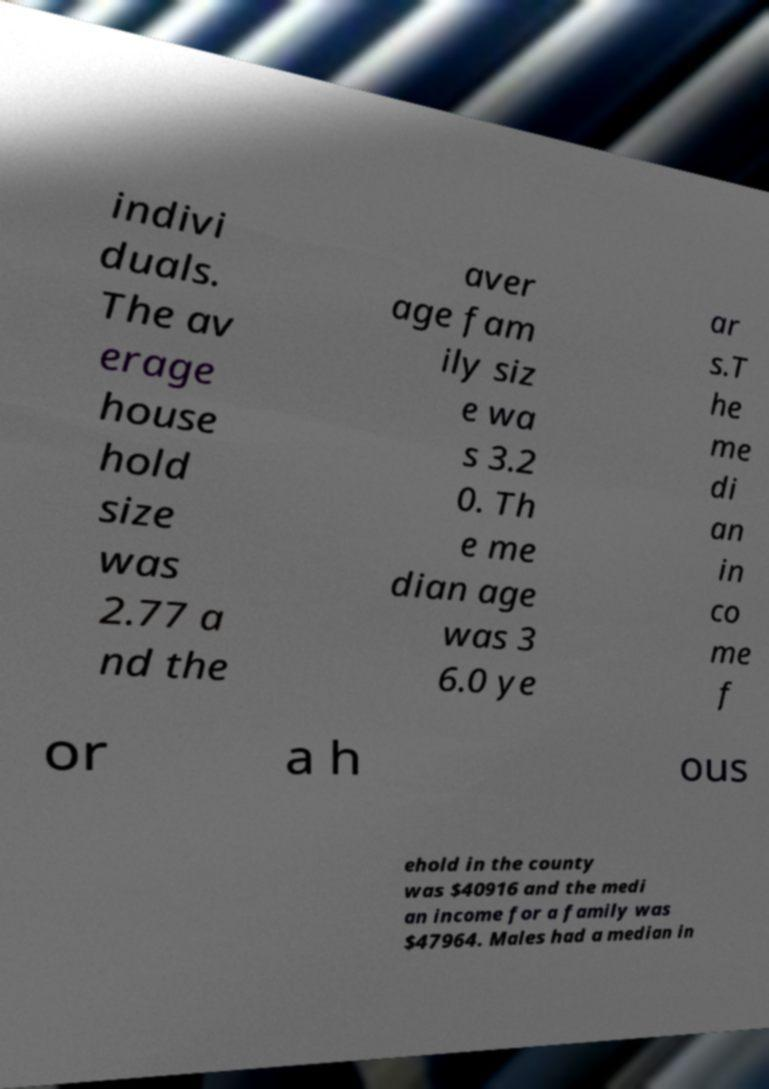Can you accurately transcribe the text from the provided image for me? indivi duals. The av erage house hold size was 2.77 a nd the aver age fam ily siz e wa s 3.2 0. Th e me dian age was 3 6.0 ye ar s.T he me di an in co me f or a h ous ehold in the county was $40916 and the medi an income for a family was $47964. Males had a median in 